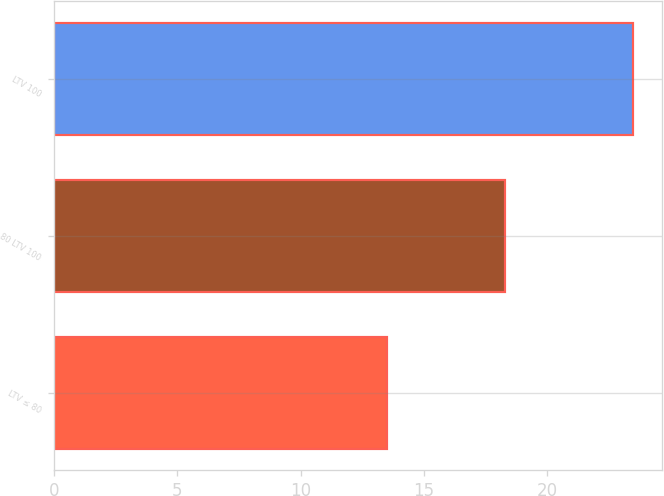Convert chart. <chart><loc_0><loc_0><loc_500><loc_500><bar_chart><fcel>LTV ≤ 80<fcel>80 LTV 100<fcel>LTV 100<nl><fcel>13.5<fcel>18.3<fcel>23.5<nl></chart> 